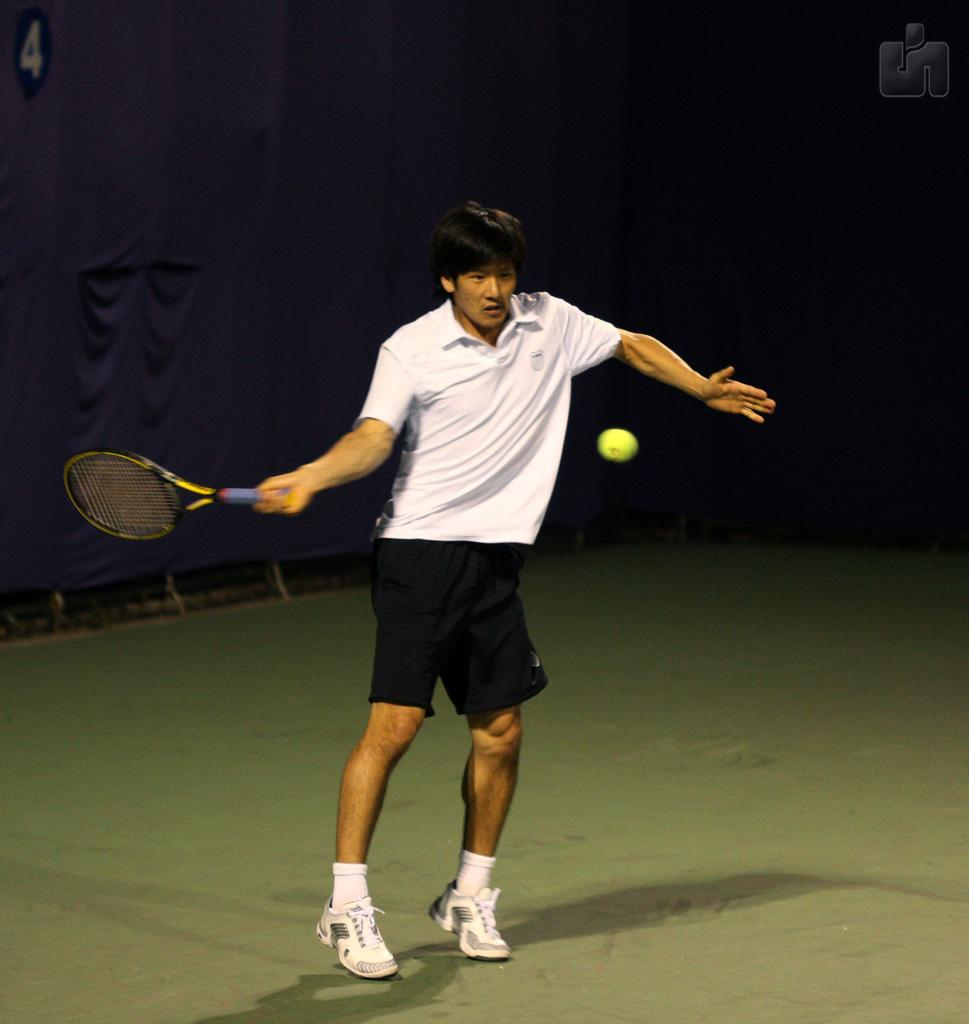Who is present in the image? There is a man in the image. What is the man wearing? The man is wearing a white t-shirt. What is the man holding in the image? The man is holding a racket. What is the purpose of the racket? The racket is meant for hitting a ball. What can be seen in the background of the image? There is a blue curtain in the image. What type of tax is being discussed by the man in the image? There is no discussion of tax in the image, as the man is holding a racket. What is the man using to store his arrows in the image? There are no arrows or quiver present in the image. 